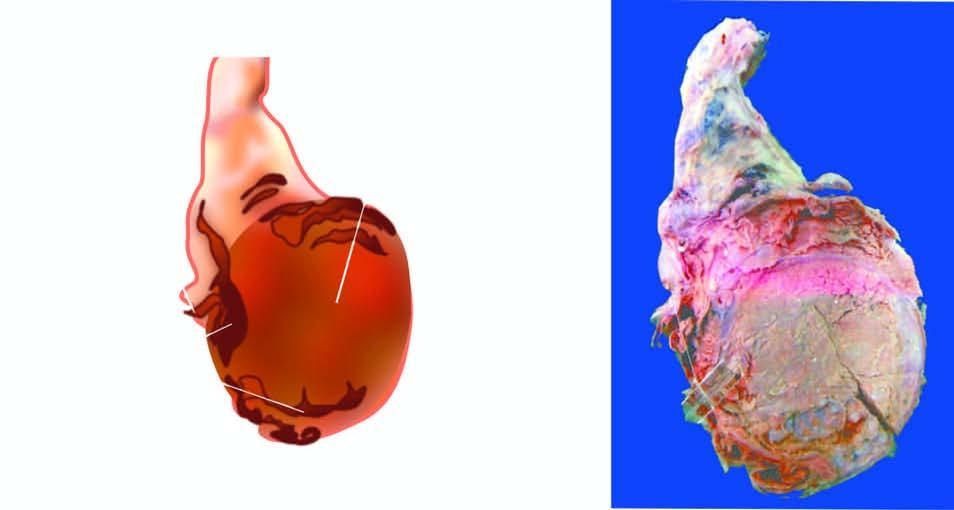what is enlarged and nodular distorting the testicular contour?
Answer the question using a single word or phrase. Testis 